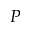<formula> <loc_0><loc_0><loc_500><loc_500>P</formula> 